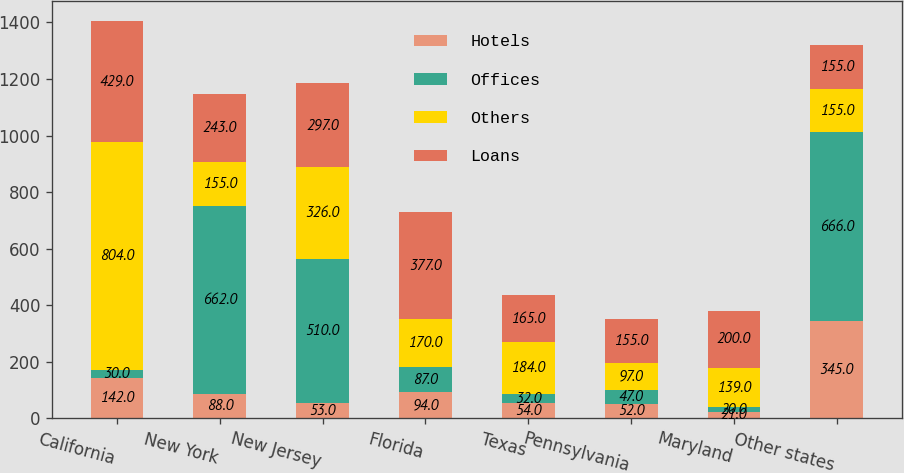Convert chart. <chart><loc_0><loc_0><loc_500><loc_500><stacked_bar_chart><ecel><fcel>California<fcel>New York<fcel>New Jersey<fcel>Florida<fcel>Texas<fcel>Pennsylvania<fcel>Maryland<fcel>Other states<nl><fcel>Hotels<fcel>142<fcel>88<fcel>53<fcel>94<fcel>54<fcel>52<fcel>21<fcel>345<nl><fcel>Offices<fcel>30<fcel>662<fcel>510<fcel>87<fcel>32<fcel>47<fcel>20<fcel>666<nl><fcel>Others<fcel>804<fcel>155<fcel>326<fcel>170<fcel>184<fcel>97<fcel>139<fcel>155<nl><fcel>Loans<fcel>429<fcel>243<fcel>297<fcel>377<fcel>165<fcel>155<fcel>200<fcel>155<nl></chart> 